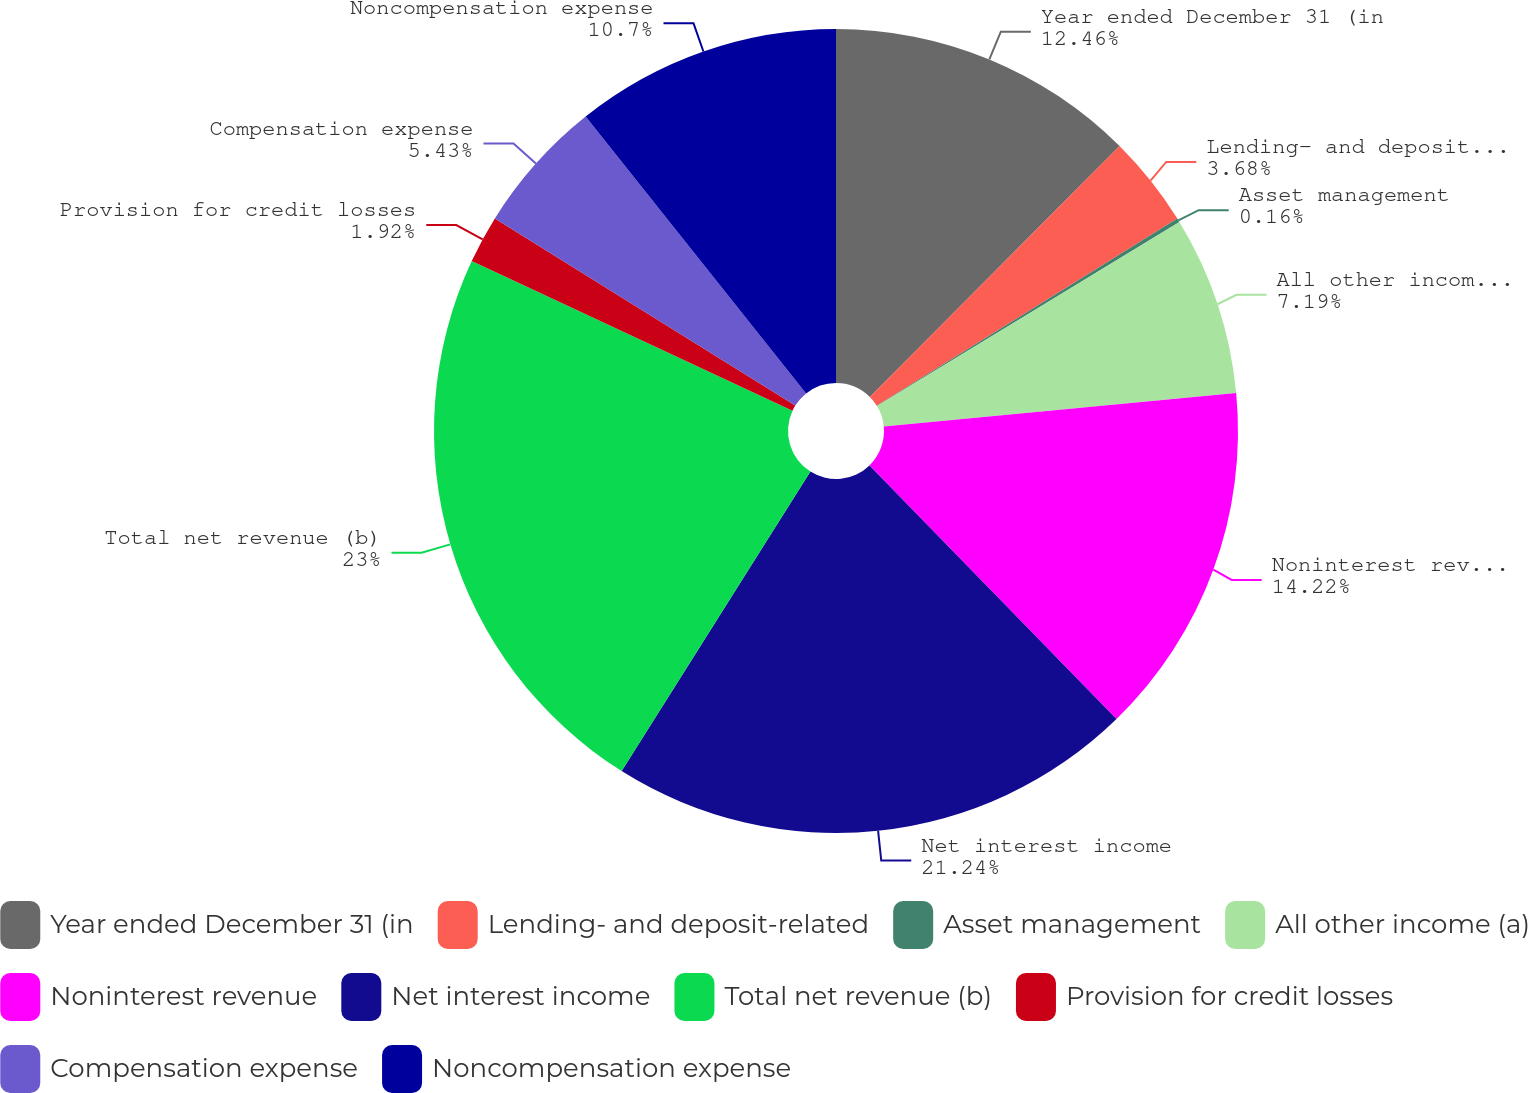Convert chart to OTSL. <chart><loc_0><loc_0><loc_500><loc_500><pie_chart><fcel>Year ended December 31 (in<fcel>Lending- and deposit-related<fcel>Asset management<fcel>All other income (a)<fcel>Noninterest revenue<fcel>Net interest income<fcel>Total net revenue (b)<fcel>Provision for credit losses<fcel>Compensation expense<fcel>Noncompensation expense<nl><fcel>12.46%<fcel>3.68%<fcel>0.16%<fcel>7.19%<fcel>14.22%<fcel>21.24%<fcel>23.0%<fcel>1.92%<fcel>5.43%<fcel>10.7%<nl></chart> 